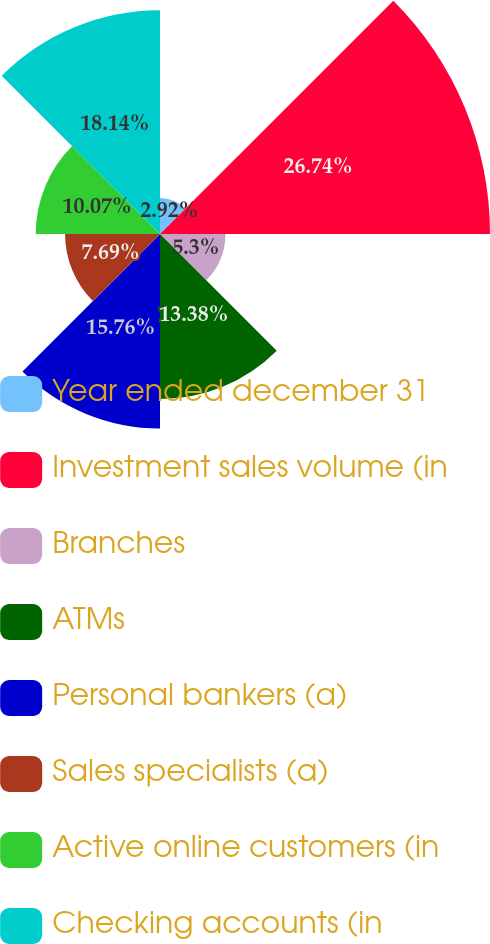Convert chart to OTSL. <chart><loc_0><loc_0><loc_500><loc_500><pie_chart><fcel>Year ended december 31<fcel>Investment sales volume (in<fcel>Branches<fcel>ATMs<fcel>Personal bankers (a)<fcel>Sales specialists (a)<fcel>Active online customers (in<fcel>Checking accounts (in<nl><fcel>2.92%<fcel>26.74%<fcel>5.3%<fcel>13.38%<fcel>15.76%<fcel>7.69%<fcel>10.07%<fcel>18.14%<nl></chart> 